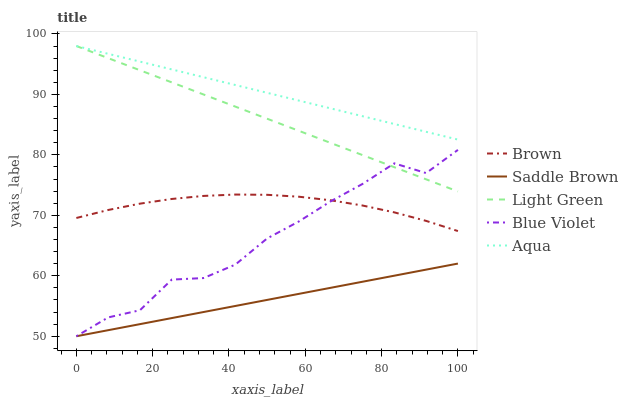Does Brown have the minimum area under the curve?
Answer yes or no. No. Does Brown have the maximum area under the curve?
Answer yes or no. No. Is Brown the smoothest?
Answer yes or no. No. Is Brown the roughest?
Answer yes or no. No. Does Brown have the lowest value?
Answer yes or no. No. Does Brown have the highest value?
Answer yes or no. No. Is Blue Violet less than Aqua?
Answer yes or no. Yes. Is Brown greater than Saddle Brown?
Answer yes or no. Yes. Does Blue Violet intersect Aqua?
Answer yes or no. No. 